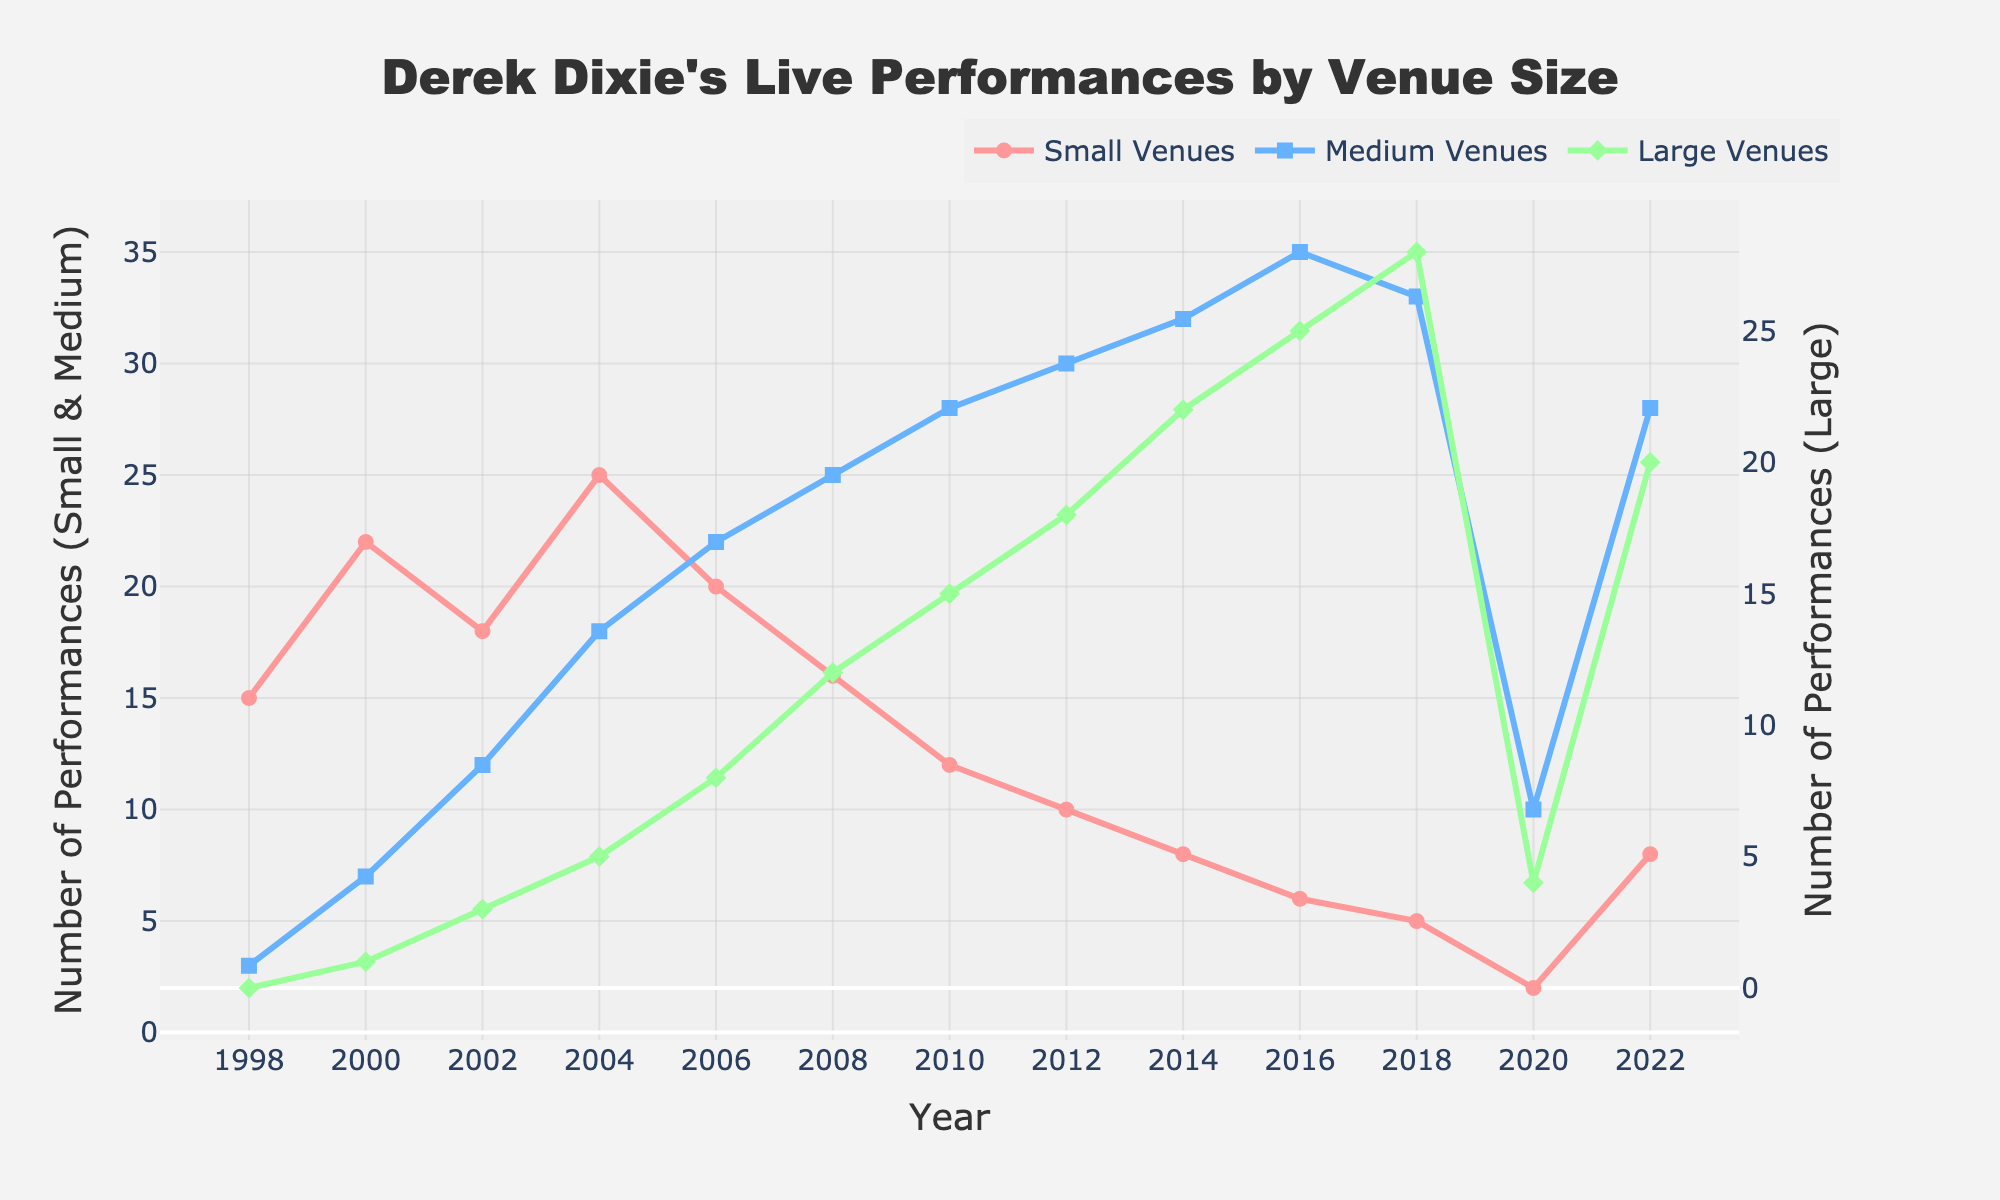What's the trend in small venue performances over the years? The trend in small venue performances can be observed by following the pink line representing small venues. Starting from 1998, it peaks in 2004, then gradually declines until it hits a low point in 2020, after which it slightly increases.
Answer: Decreasing trend Which venue type had the most performances in 2016, and how many were there? In 2016, the blue line representing medium venues had the most performances. The figure shows that medium venues had 35 performances that year.
Answer: Medium venues, 35 What is the difference in the number of performances between small and large venues in 2008? In 2008, small venues had 16 performances and large venues had 12 performances. The difference is calculated as 16 - 12 = 4.
Answer: 4 Between which years did large venues see the highest increase in performances? By observing the green line representing large venues, it's clear that the sharpest increase occurred between 2006 (8 performances) and 2008 (12 performances), showing an increase of 4.
Answer: Between 2006 and 2008 Which year had the highest combined total of performances for all venue sizes, and what was the total? Adding up the performances for each year, the highest combined total is observed in 2016. Small: 6, Medium: 35, Large: 25. The total is 6 + 35 + 25 = 66.
Answer: 2016, 66 How did the number of performances at small venues change from 2010 to 2012? The number of performances at small venues decreased from 12 in 2010 to 10 in 2012. This represents a decrease of 12 - 10 = 2.
Answer: Decreased by 2 On average, how many performances were held at large venues between 2010 and 2014? The number of large venue performances in 2010, 2012, and 2014 were 15, 18, and 22 respectively. The average can be calculated as (15 + 18 + 22) / 3 = 18.33.
Answer: 18.33 What is the difference in the number of medium venue performances between 2002 and 2020? In 2002, there were 12 medium venue performances and in 2020, there were 10. The difference is calculated as 12 - 10 = 2.
Answer: 2 In which year did small venues have fewer than 10 performances for the first time, and how many performances were there? By analyzing the pink line, it is evident that in 2014, the number of performances at small venues dropped below 10 for the first time, totaling 8 performances.
Answer: 2014, 8 What is the overall trend observed in medium venue performances from 1998 to 2022? The trend can be assessed by following the blue line. Medium venue performances started low in early years, progressively increased until peaking around 2016, then slightly decreased in 2020 before increasing again in 2022.
Answer: Increasing trend 